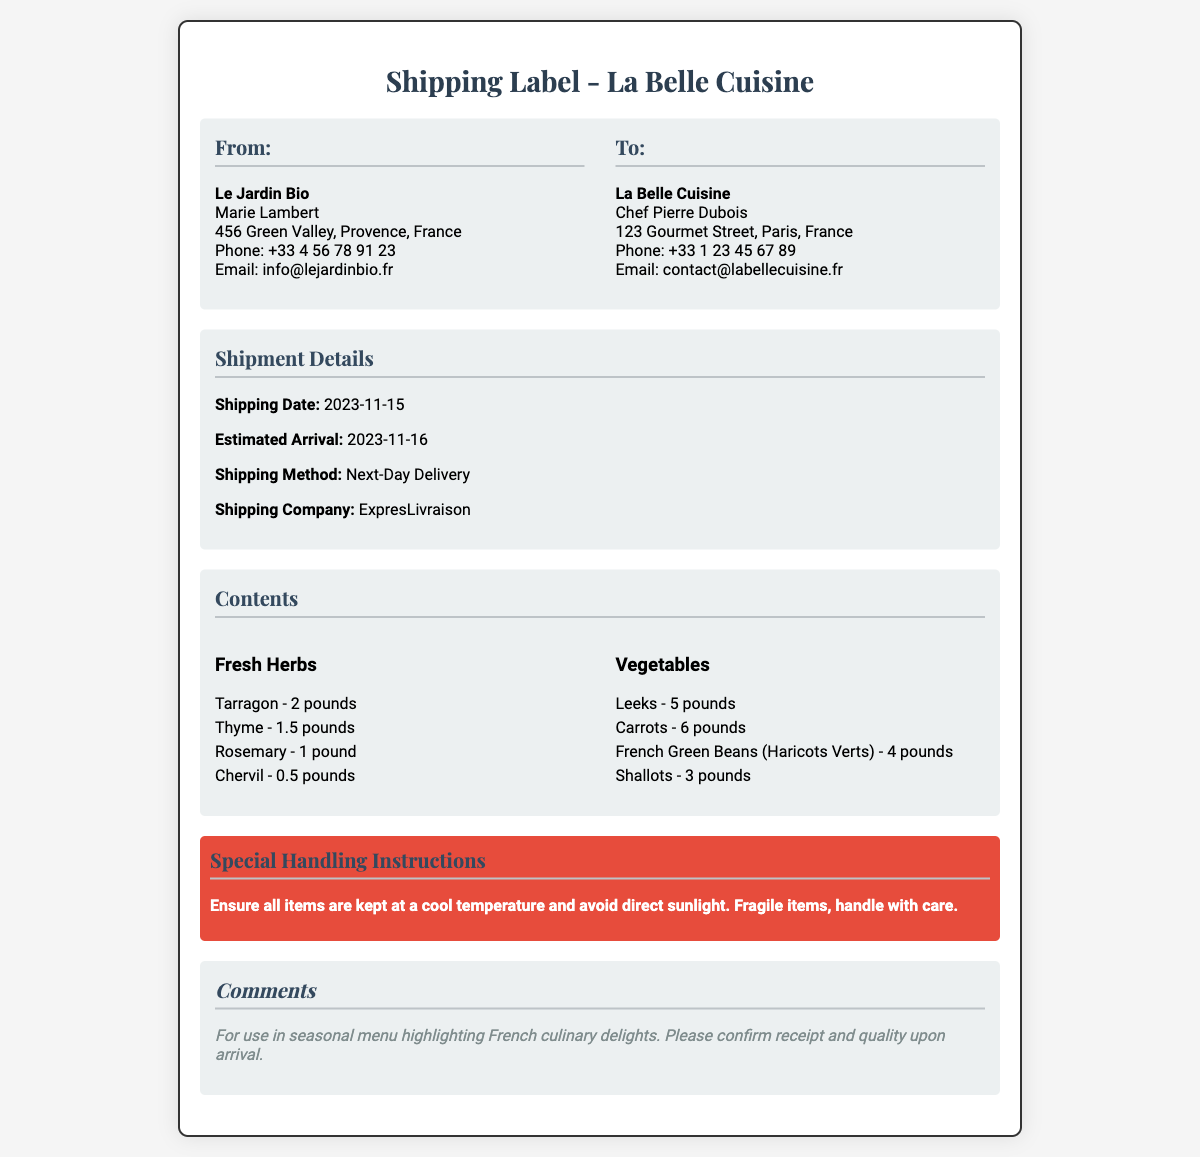What is the name of the sender? The sender is identified as "Le Jardin Bio" in the shipping label.
Answer: Le Jardin Bio What is the phone number of the recipient? The recipient's phone number is listed in the document under "To: La Belle Cuisine."
Answer: +33 1 23 45 67 89 How much tarragon is included in the shipment? The quantity of tarragon is specified in the "Contents" section under "Fresh Herbs."
Answer: 2 pounds What is the estimated arrival date? The document provides the estimated arrival date in the "Shipment Details" section.
Answer: 2023-11-16 What shipping method is being used? The shipping method is mentioned in the "Shipment Details" section of the document.
Answer: Next-Day Delivery How many pounds of carrots are in the shipment? The document lists the amount of carrots under "Vegetables" in the "Contents" section.
Answer: 6 pounds What special handling instruction is provided? The handling instruction states specific care requirements found under "Special Handling Instructions."
Answer: Ensure all items are kept at a cool temperature What is the purpose of the shipment mentioned in the comments? The comments section indicates the intended use of the shipment.
Answer: Seasonal menu highlighting French culinary delights 